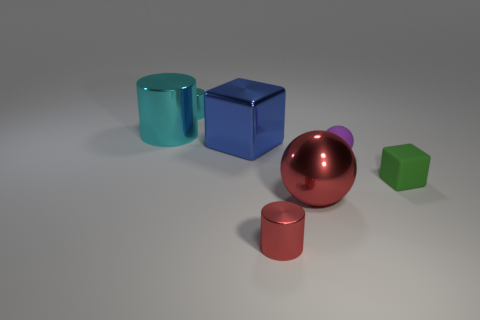How many big red spheres are left of the metallic thing that is right of the red cylinder?
Your answer should be very brief. 0. Is there a blue object?
Ensure brevity in your answer.  Yes. Is there a large purple object made of the same material as the purple ball?
Provide a succinct answer. No. Is the number of blue objects that are in front of the large red shiny object greater than the number of red metal spheres in front of the large shiny block?
Keep it short and to the point. No. Do the red shiny sphere and the red cylinder have the same size?
Keep it short and to the point. No. There is a tiny metal cylinder behind the tiny thing on the right side of the purple object; what is its color?
Offer a very short reply. Cyan. The big ball has what color?
Offer a very short reply. Red. Is there a small matte ball that has the same color as the large cylinder?
Give a very brief answer. No. Does the rubber object in front of the purple thing have the same color as the big ball?
Make the answer very short. No. What number of things are metallic cylinders that are behind the tiny block or big green cylinders?
Provide a short and direct response. 2. 